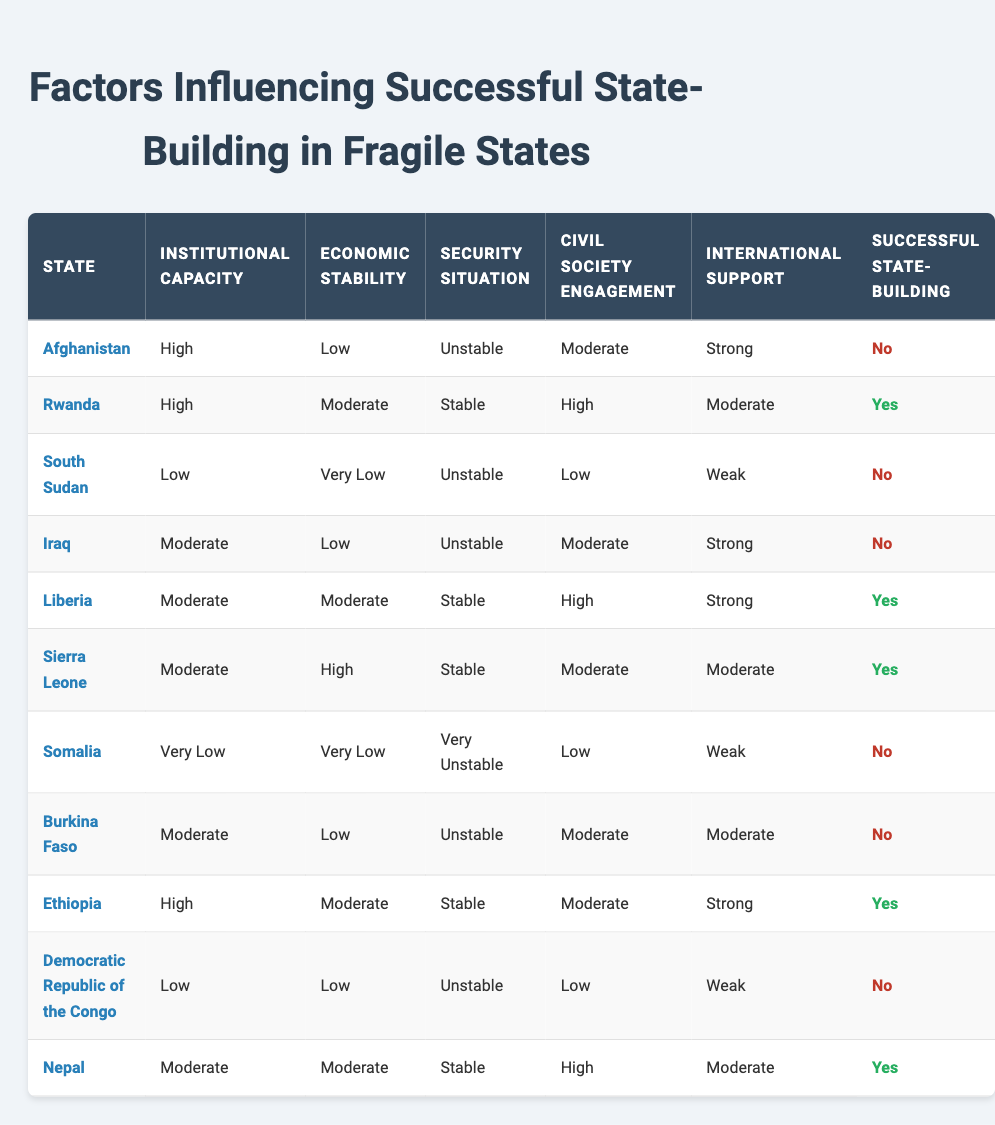What is the state with the highest institutional capacity that has successful state building? The highest institutional capacity is "High," and from the table, the states with "High" capacity are Afghanistan and Rwanda. Among them, only Rwanda has been successful in state building.
Answer: Rwanda How many states have a low economic stability and have not succeeded in state building? The states with "Low" economic stability are Afghanistan, Iraq, and Burkina Faso. Out of these, Afghanistan and Iraq have not succeeded in state building, while Burkina Faso has failed as well. Thus, all three have not succeeded in state building.
Answer: 3 Has Somalia achieved successful state building? In the table, Somalia is listed with a status of "No" under successful state building.
Answer: No What is the average economic stability level for states that have successfully built their state? The successful states are Rwanda, Liberia, Sierra Leone, Ethiopia, and Nepal, with economic stability levels of Moderate, Moderate, High, Moderate, and Moderate, respectively. Summing these values, we can assign numerical values (Low=1, Moderate=2, High=3). The sum is 2 + 2 + 3 + 2 + 2 = 11. There are 5 states, so the average is 11/5 = 2.2, which corresponds to the Moderate level of economic stability.
Answer: Moderate Which factors are present in states that have not achieved successful state building? Reviewing the table, factors common among the unsuccessful states (Afghanistan, South Sudan, Iraq, Somalia, Burkina Faso, Democratic Republic of the Congo) include low institutional capacity (Low and Moderate), unstable security situations, and weak international support in most cases.
Answer: High instability, low capacity, weak support How many states have a high level of civil society engagement and have succeeded in state building? From the table, only Rwanda has a "High" level of civil society engagement among successful states. Liberia and Nepal have moderate engagement and are also successful but do not count in this specific category. Thus, Rwanda is the only state in this context.
Answer: 1 What is the security situation of the states that have succeeded in state building? The successful states (Rwanda, Liberia, Sierra Leone, Ethiopia, and Nepal) all exhibit a "Stable" security situation except for Sierra Leone, which had moderate engagement, but high economic stability mitigated its instability. Thus, all have stable or improving circumstances when their state is built.
Answer: Stable How many states listed have moderate international support and have not achieved successful state building? The states with moderate international support are Liberia, Sierra Leone, and Burkina Faso; however, only Burkina Faso is noted as having not achieved successful state building based on its factors.
Answer: 1 